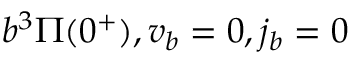Convert formula to latex. <formula><loc_0><loc_0><loc_500><loc_500>b ^ { 3 } \Pi ( 0 ^ { + } ) , v _ { b } = 0 , j _ { b } = 0</formula> 